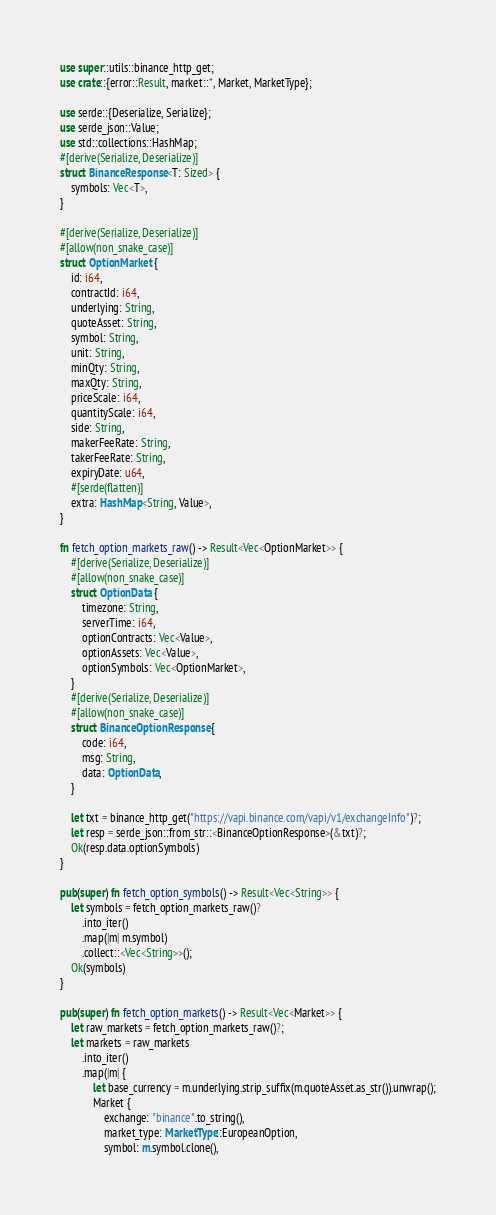Convert code to text. <code><loc_0><loc_0><loc_500><loc_500><_Rust_>use super::utils::binance_http_get;
use crate::{error::Result, market::*, Market, MarketType};

use serde::{Deserialize, Serialize};
use serde_json::Value;
use std::collections::HashMap;
#[derive(Serialize, Deserialize)]
struct BinanceResponse<T: Sized> {
    symbols: Vec<T>,
}

#[derive(Serialize, Deserialize)]
#[allow(non_snake_case)]
struct OptionMarket {
    id: i64,
    contractId: i64,
    underlying: String,
    quoteAsset: String,
    symbol: String,
    unit: String,
    minQty: String,
    maxQty: String,
    priceScale: i64,
    quantityScale: i64,
    side: String,
    makerFeeRate: String,
    takerFeeRate: String,
    expiryDate: u64,
    #[serde(flatten)]
    extra: HashMap<String, Value>,
}

fn fetch_option_markets_raw() -> Result<Vec<OptionMarket>> {
    #[derive(Serialize, Deserialize)]
    #[allow(non_snake_case)]
    struct OptionData {
        timezone: String,
        serverTime: i64,
        optionContracts: Vec<Value>,
        optionAssets: Vec<Value>,
        optionSymbols: Vec<OptionMarket>,
    }
    #[derive(Serialize, Deserialize)]
    #[allow(non_snake_case)]
    struct BinanceOptionResponse {
        code: i64,
        msg: String,
        data: OptionData,
    }

    let txt = binance_http_get("https://vapi.binance.com/vapi/v1/exchangeInfo")?;
    let resp = serde_json::from_str::<BinanceOptionResponse>(&txt)?;
    Ok(resp.data.optionSymbols)
}

pub(super) fn fetch_option_symbols() -> Result<Vec<String>> {
    let symbols = fetch_option_markets_raw()?
        .into_iter()
        .map(|m| m.symbol)
        .collect::<Vec<String>>();
    Ok(symbols)
}

pub(super) fn fetch_option_markets() -> Result<Vec<Market>> {
    let raw_markets = fetch_option_markets_raw()?;
    let markets = raw_markets
        .into_iter()
        .map(|m| {
            let base_currency = m.underlying.strip_suffix(m.quoteAsset.as_str()).unwrap();
            Market {
                exchange: "binance".to_string(),
                market_type: MarketType::EuropeanOption,
                symbol: m.symbol.clone(),</code> 